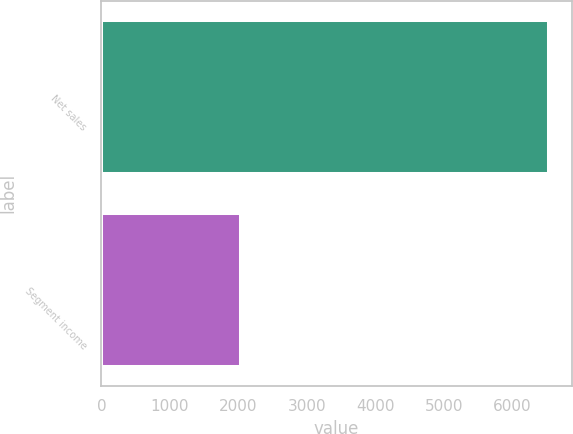<chart> <loc_0><loc_0><loc_500><loc_500><bar_chart><fcel>Net sales<fcel>Segment income<nl><fcel>6533<fcel>2041<nl></chart> 